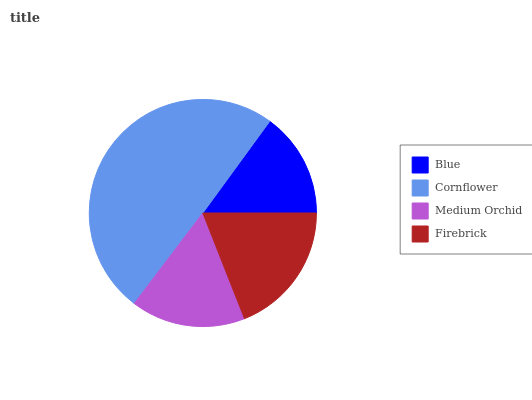Is Blue the minimum?
Answer yes or no. Yes. Is Cornflower the maximum?
Answer yes or no. Yes. Is Medium Orchid the minimum?
Answer yes or no. No. Is Medium Orchid the maximum?
Answer yes or no. No. Is Cornflower greater than Medium Orchid?
Answer yes or no. Yes. Is Medium Orchid less than Cornflower?
Answer yes or no. Yes. Is Medium Orchid greater than Cornflower?
Answer yes or no. No. Is Cornflower less than Medium Orchid?
Answer yes or no. No. Is Firebrick the high median?
Answer yes or no. Yes. Is Medium Orchid the low median?
Answer yes or no. Yes. Is Medium Orchid the high median?
Answer yes or no. No. Is Blue the low median?
Answer yes or no. No. 